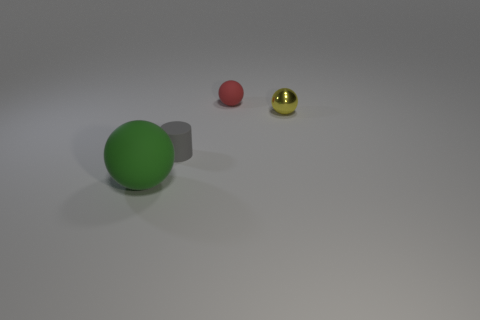Are there any small red spheres?
Offer a very short reply. Yes. Does the small gray rubber thing have the same shape as the tiny matte thing that is behind the gray rubber object?
Keep it short and to the point. No. There is a object on the left side of the small rubber thing to the left of the small red object; what is it made of?
Make the answer very short. Rubber. What is the color of the large object?
Ensure brevity in your answer.  Green. There is a rubber ball that is right of the green ball; is its color the same as the ball in front of the tiny yellow shiny ball?
Provide a succinct answer. No. The red rubber thing that is the same shape as the large green thing is what size?
Provide a succinct answer. Small. Is there a shiny thing of the same color as the large ball?
Provide a short and direct response. No. How many small cylinders are the same color as the small matte sphere?
Your answer should be compact. 0. What number of objects are rubber objects in front of the red matte sphere or matte balls?
Offer a terse response. 3. The small ball that is made of the same material as the gray thing is what color?
Give a very brief answer. Red. 